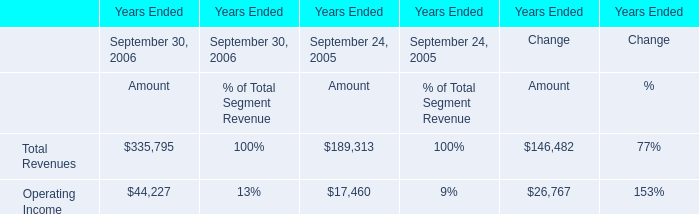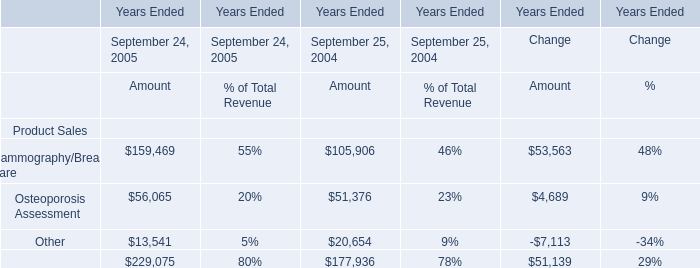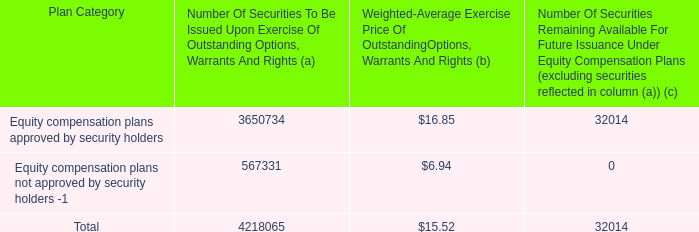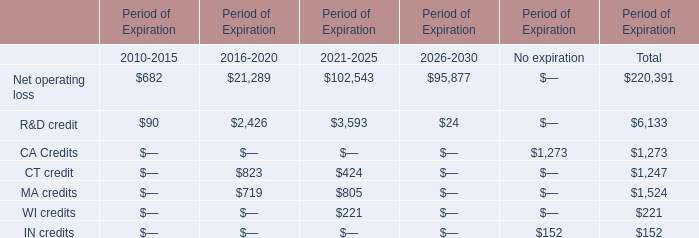What is the average amount of Other of Years Ended September 24, 2005 Amount, and CA Credits of Period of Expiration No expiration ? 
Computations: ((13541.0 + 1273.0) / 2)
Answer: 7407.0. 